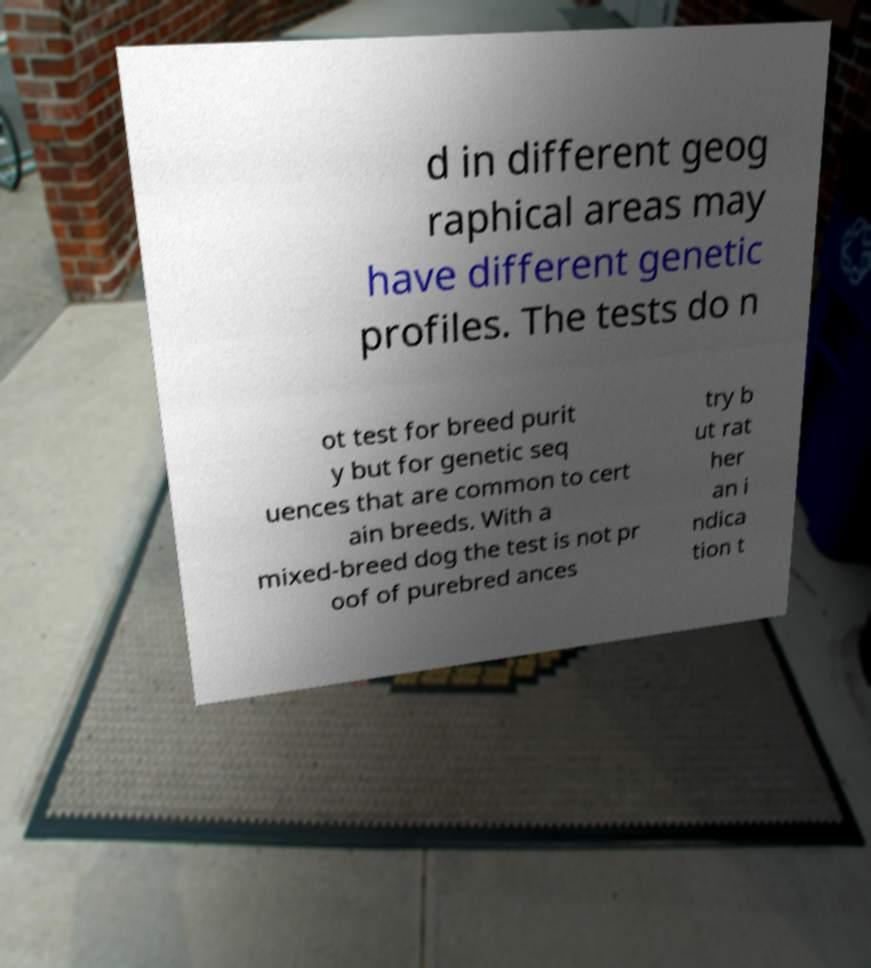For documentation purposes, I need the text within this image transcribed. Could you provide that? d in different geog raphical areas may have different genetic profiles. The tests do n ot test for breed purit y but for genetic seq uences that are common to cert ain breeds. With a mixed-breed dog the test is not pr oof of purebred ances try b ut rat her an i ndica tion t 